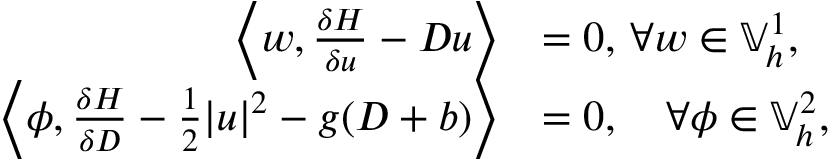Convert formula to latex. <formula><loc_0><loc_0><loc_500><loc_500>\begin{array} { r l } { \left \langle w , \frac { \delta H } { \delta u } - D u \right \rangle } & { = 0 , \, \forall w \in \mathbb { V } _ { h } ^ { 1 } , } \\ { \left \langle \phi , \frac { \delta H } { \delta D } - \frac { 1 } { 2 } | u | ^ { 2 } - g ( D + b ) \right \rangle } & { = 0 , \quad \forall \phi \in \mathbb { V } _ { h } ^ { 2 } , } \end{array}</formula> 